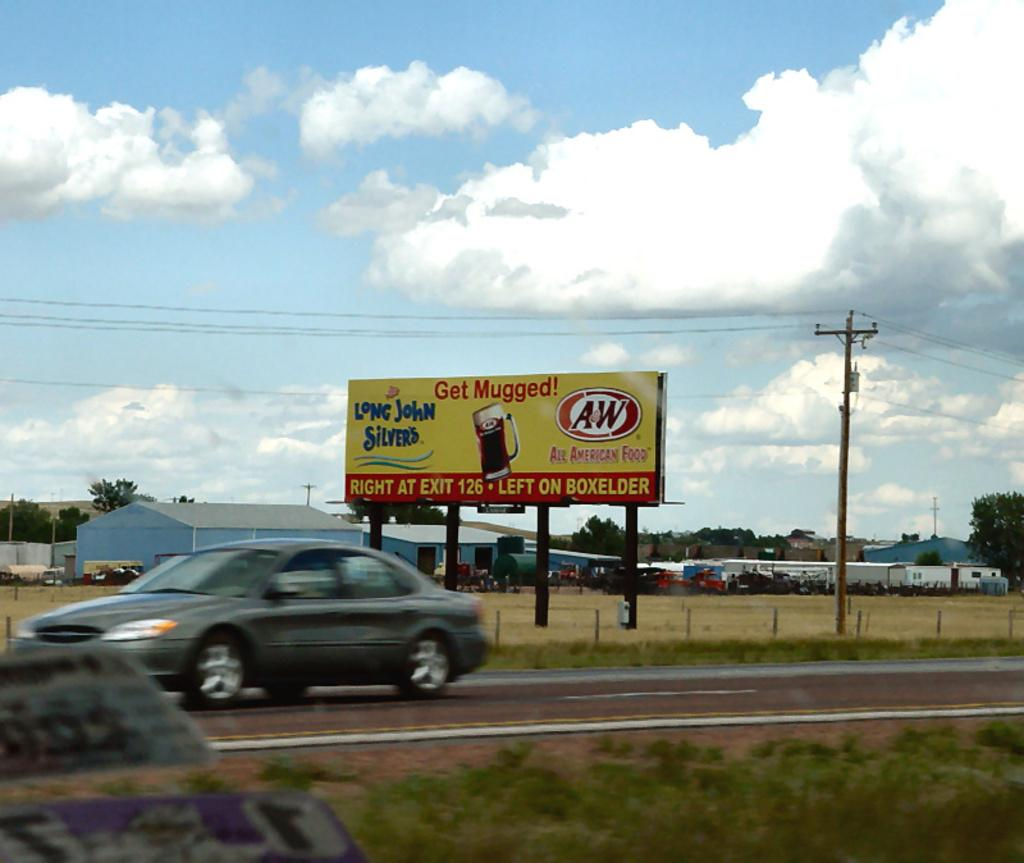<image>
Relay a brief, clear account of the picture shown. A billboard for AW rootbeer and Long John Silvers sits next to a highway 